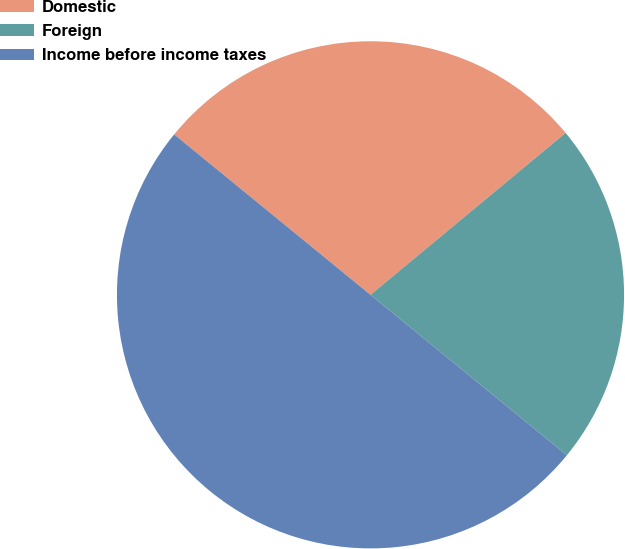Convert chart to OTSL. <chart><loc_0><loc_0><loc_500><loc_500><pie_chart><fcel>Domestic<fcel>Foreign<fcel>Income before income taxes<nl><fcel>28.07%<fcel>21.93%<fcel>50.0%<nl></chart> 